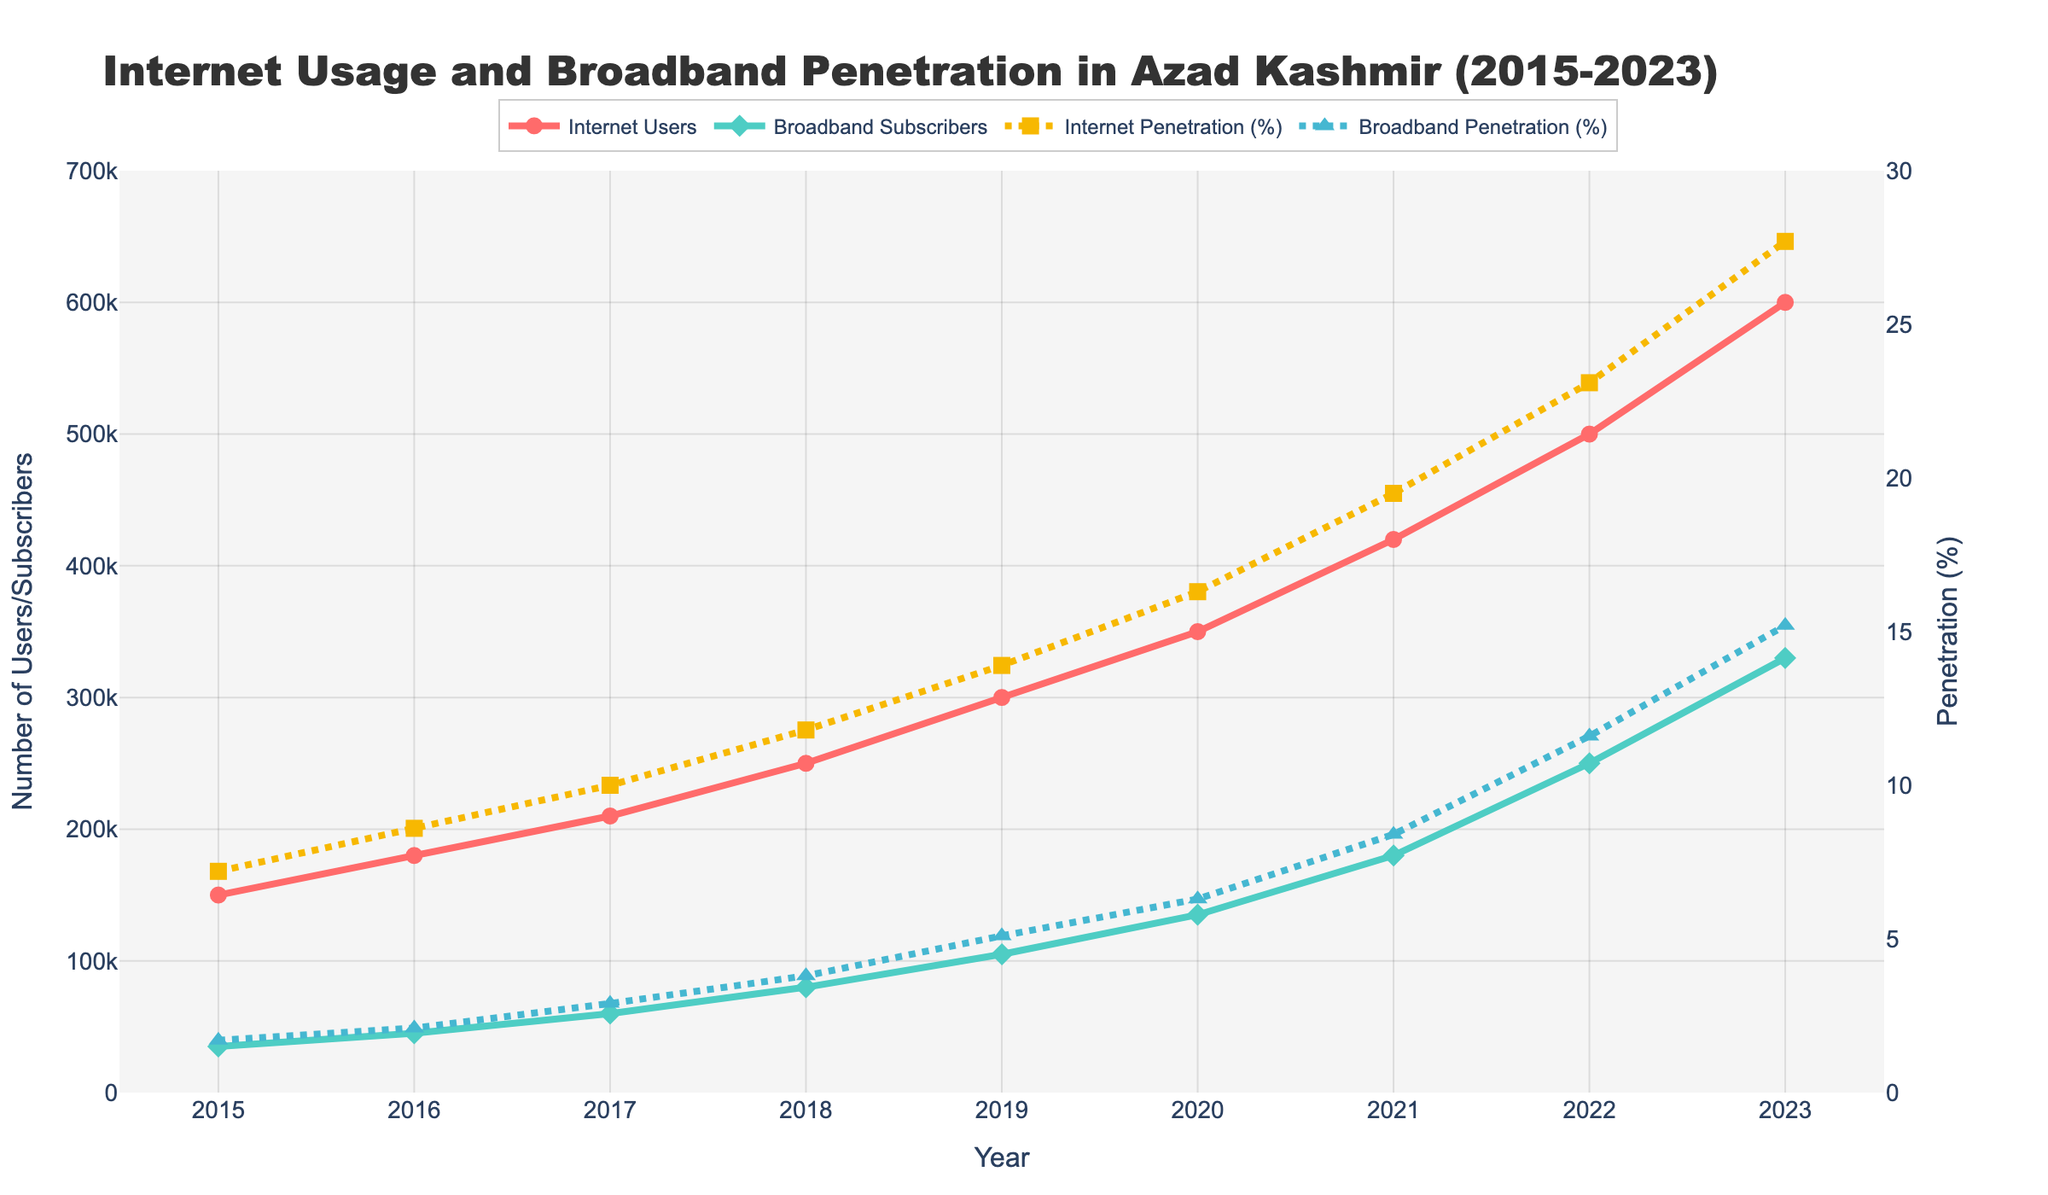What is the color of the line representing Internet Users? The color of the line can be identified by looking at the figure's legend and corresponding line. The Internet Users are represented by a red line.
Answer: Red How many Internet Users are there in 2018? Refer to the plot and find the data point for Internet Users in the year 2018. According to the data point, there are 250,000 Internet Users in 2018.
Answer: 250,000 Which year shows the highest Broadband Penetration (%)? Look at the plot for the dashed-dot line representing Broadband Penetration (%) and find the highest point. The year that corresponds to this highest point is 2023.
Answer: 2023 What is the difference in Internet Penetration (%) between 2022 and 2023? Identify the Internet Penetration for 2022 and 2023 from the plot (23.1% and 27.7%, respectively) and subtract the former from the latter: 27.7% - 23.1% = 4.6%.
Answer: 4.6% By how much did Broadband Subscribers increase from 2015 to 2023? Find the data points for Broadband Subscribers in the years 2015 and 2023 (35,000 and 330,000, respectively). Subtract the former from the latter: 330,000 - 35,000 = 295,000.
Answer: 295,000 In which year did Internet Penetration (%) exceed 10% for the first time? Trace the dashed-dot line representing Internet Penetration (%) and find the first year where the value exceeds 10%. According to the plot, this occurs in 2017.
Answer: 2017 Compare the growth in Internet Users between 2015 and 2020 to the growth between 2020 and 2023. Which period had higher growth? Calculate the growth in Internet Users from 2015 to 2020 by finding the difference: 350,000 - 150,000 = 200,000. Then calculate the growth from 2020 to 2023: 600,000 - 350,000 = 250,000. The latter period had higher growth.
Answer: 2020-2023 What is the average Internet Penetration (%) over the years shown? Sum the Internet Penetration values: 7.2 + 8.6 + 10.0 + 11.8 + 13.9 + 16.3 + 19.5 + 23.1 + 27.7 = 138.1. The number of years is 9, so the average is 138.1 / 9 ≈ 15.34%.
Answer: 15.34% How do Broadband Penetration (%) and Internet Penetration (%) compare in 2023? Refer to the plot and find the penetration rates for both metrics in 2023. Broadband Penetration is 15.2%, and Internet Penetration is 27.7%.
Answer: Internet Penetration is higher in 2023 What trend do you observe in Internet Users and Broadband Subscribers from 2015 to 2023? Observe the trend lines for Internet Users and Broadband Subscribers. Both show a steady increase over the years.
Answer: Steadily increasing 